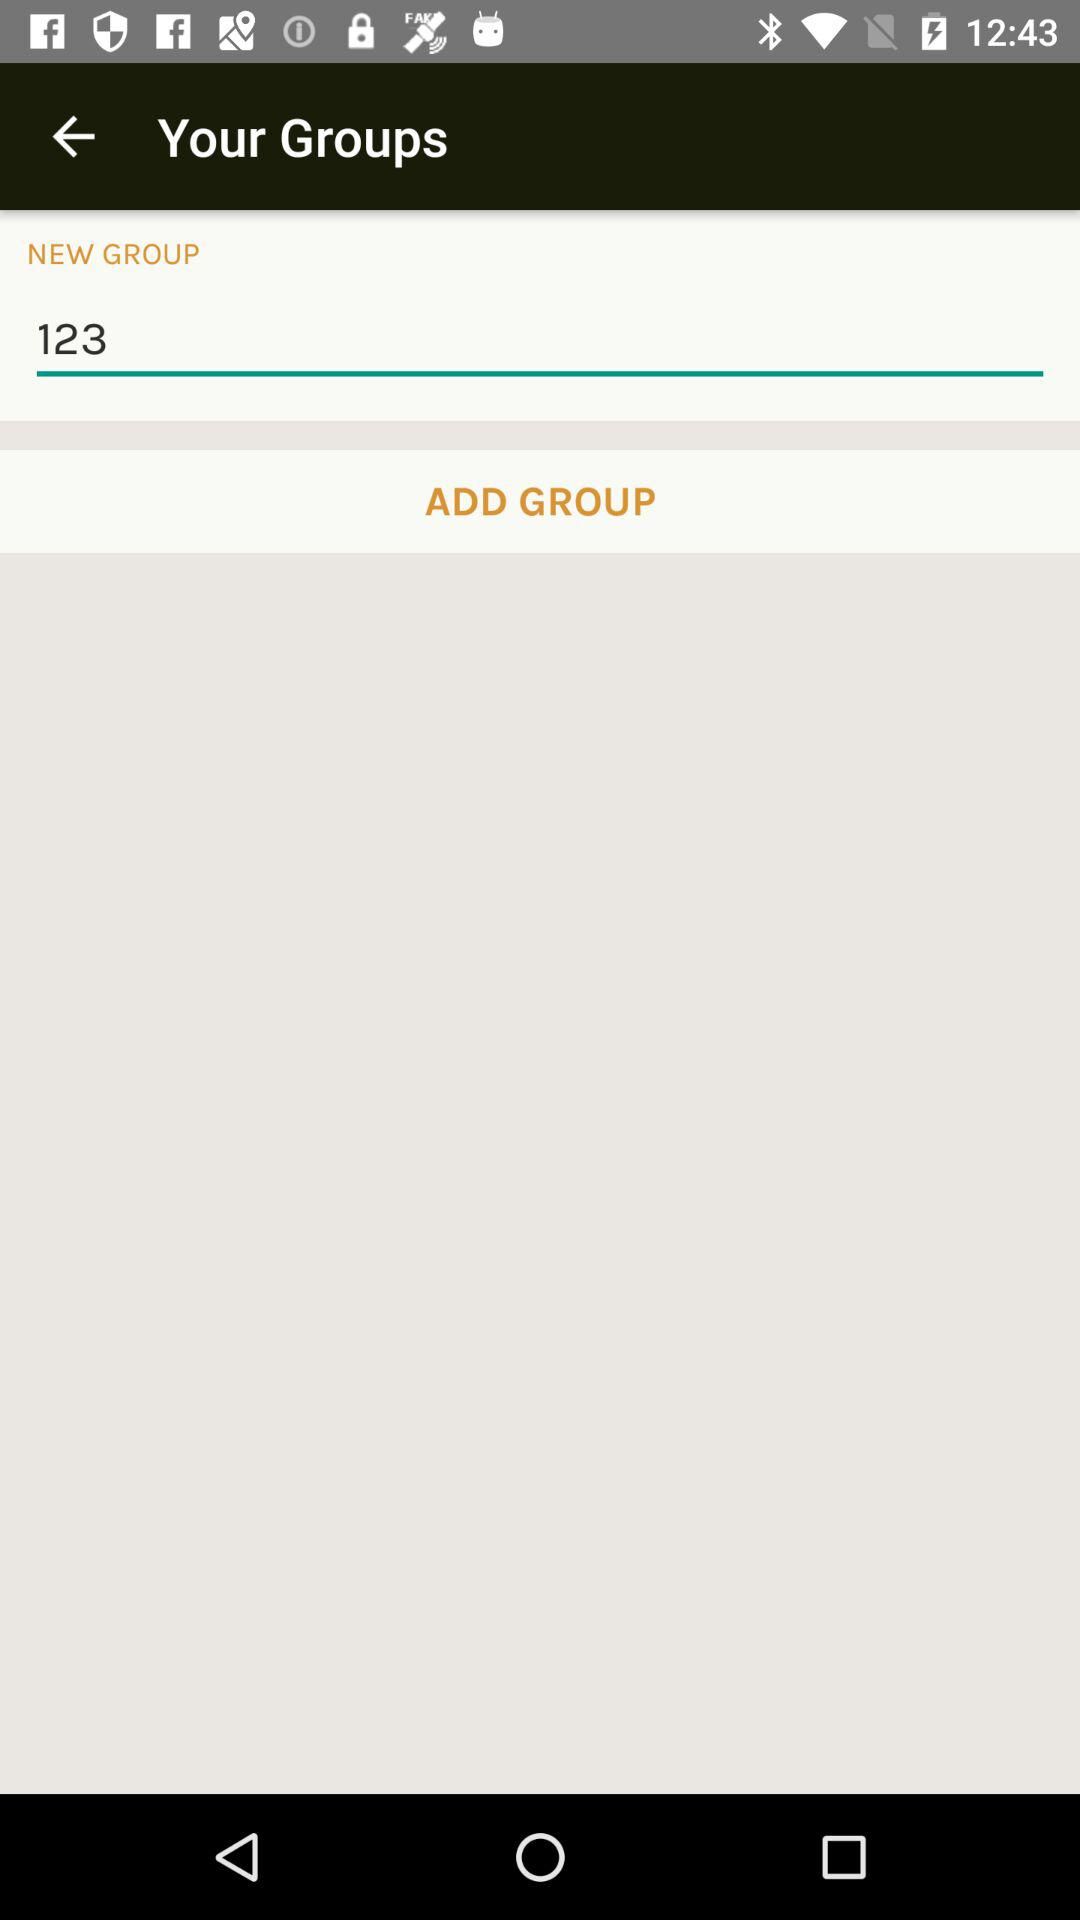When was the group created?
When the provided information is insufficient, respond with <no answer>. <no answer> 